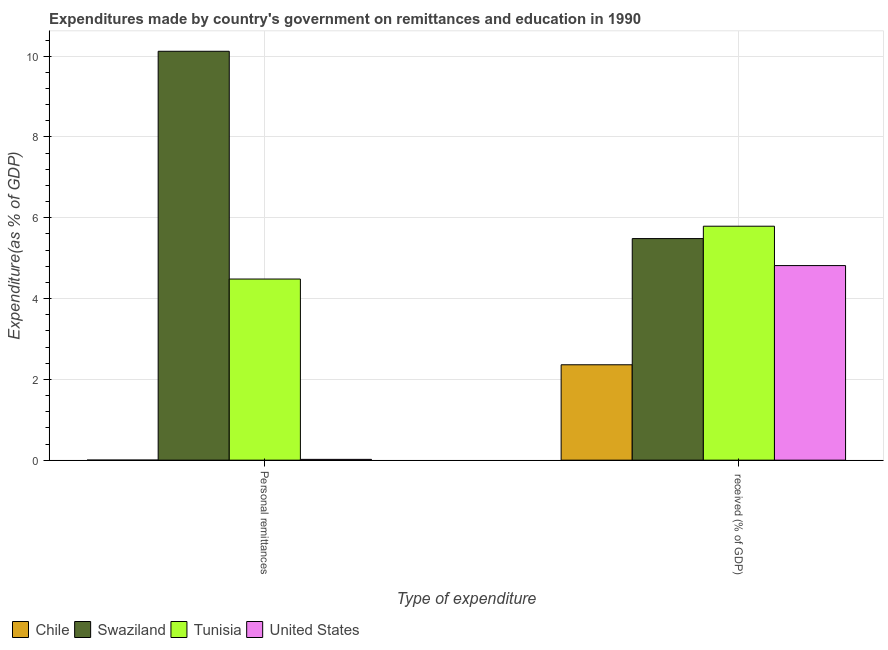Are the number of bars on each tick of the X-axis equal?
Your answer should be compact. Yes. How many bars are there on the 2nd tick from the left?
Provide a short and direct response. 4. What is the label of the 1st group of bars from the left?
Ensure brevity in your answer.  Personal remittances. What is the expenditure in education in Tunisia?
Offer a terse response. 5.79. Across all countries, what is the maximum expenditure in education?
Ensure brevity in your answer.  5.79. Across all countries, what is the minimum expenditure in education?
Your answer should be very brief. 2.36. In which country was the expenditure in personal remittances maximum?
Give a very brief answer. Swaziland. What is the total expenditure in education in the graph?
Offer a very short reply. 18.45. What is the difference between the expenditure in education in United States and that in Swaziland?
Your response must be concise. -0.67. What is the difference between the expenditure in personal remittances in Chile and the expenditure in education in Swaziland?
Provide a succinct answer. -5.48. What is the average expenditure in personal remittances per country?
Your response must be concise. 3.66. What is the difference between the expenditure in personal remittances and expenditure in education in Tunisia?
Keep it short and to the point. -1.31. What is the ratio of the expenditure in personal remittances in Swaziland to that in United States?
Your response must be concise. 517.27. Is the expenditure in personal remittances in Swaziland less than that in United States?
Your response must be concise. No. What does the 3rd bar from the left in Personal remittances represents?
Ensure brevity in your answer.  Tunisia. What does the 4th bar from the right in Personal remittances represents?
Ensure brevity in your answer.  Chile. What is the difference between two consecutive major ticks on the Y-axis?
Offer a terse response. 2. Are the values on the major ticks of Y-axis written in scientific E-notation?
Make the answer very short. No. Does the graph contain any zero values?
Keep it short and to the point. No. Does the graph contain grids?
Provide a short and direct response. Yes. What is the title of the graph?
Your answer should be compact. Expenditures made by country's government on remittances and education in 1990. What is the label or title of the X-axis?
Give a very brief answer. Type of expenditure. What is the label or title of the Y-axis?
Give a very brief answer. Expenditure(as % of GDP). What is the Expenditure(as % of GDP) in Chile in Personal remittances?
Offer a very short reply. 0. What is the Expenditure(as % of GDP) of Swaziland in Personal remittances?
Your answer should be compact. 10.12. What is the Expenditure(as % of GDP) of Tunisia in Personal remittances?
Offer a terse response. 4.48. What is the Expenditure(as % of GDP) of United States in Personal remittances?
Give a very brief answer. 0.02. What is the Expenditure(as % of GDP) of Chile in  received (% of GDP)?
Give a very brief answer. 2.36. What is the Expenditure(as % of GDP) in Swaziland in  received (% of GDP)?
Your answer should be very brief. 5.48. What is the Expenditure(as % of GDP) in Tunisia in  received (% of GDP)?
Offer a very short reply. 5.79. What is the Expenditure(as % of GDP) in United States in  received (% of GDP)?
Make the answer very short. 4.82. Across all Type of expenditure, what is the maximum Expenditure(as % of GDP) in Chile?
Provide a short and direct response. 2.36. Across all Type of expenditure, what is the maximum Expenditure(as % of GDP) in Swaziland?
Provide a succinct answer. 10.12. Across all Type of expenditure, what is the maximum Expenditure(as % of GDP) in Tunisia?
Your response must be concise. 5.79. Across all Type of expenditure, what is the maximum Expenditure(as % of GDP) in United States?
Your response must be concise. 4.82. Across all Type of expenditure, what is the minimum Expenditure(as % of GDP) of Chile?
Provide a succinct answer. 0. Across all Type of expenditure, what is the minimum Expenditure(as % of GDP) of Swaziland?
Your answer should be very brief. 5.48. Across all Type of expenditure, what is the minimum Expenditure(as % of GDP) in Tunisia?
Ensure brevity in your answer.  4.48. Across all Type of expenditure, what is the minimum Expenditure(as % of GDP) of United States?
Your answer should be very brief. 0.02. What is the total Expenditure(as % of GDP) in Chile in the graph?
Make the answer very short. 2.36. What is the total Expenditure(as % of GDP) in Swaziland in the graph?
Offer a very short reply. 15.61. What is the total Expenditure(as % of GDP) of Tunisia in the graph?
Provide a short and direct response. 10.27. What is the total Expenditure(as % of GDP) of United States in the graph?
Offer a terse response. 4.84. What is the difference between the Expenditure(as % of GDP) in Chile in Personal remittances and that in  received (% of GDP)?
Your answer should be compact. -2.36. What is the difference between the Expenditure(as % of GDP) in Swaziland in Personal remittances and that in  received (% of GDP)?
Your answer should be compact. 4.64. What is the difference between the Expenditure(as % of GDP) of Tunisia in Personal remittances and that in  received (% of GDP)?
Your response must be concise. -1.31. What is the difference between the Expenditure(as % of GDP) in United States in Personal remittances and that in  received (% of GDP)?
Offer a terse response. -4.8. What is the difference between the Expenditure(as % of GDP) of Chile in Personal remittances and the Expenditure(as % of GDP) of Swaziland in  received (% of GDP)?
Offer a terse response. -5.48. What is the difference between the Expenditure(as % of GDP) of Chile in Personal remittances and the Expenditure(as % of GDP) of Tunisia in  received (% of GDP)?
Your answer should be compact. -5.79. What is the difference between the Expenditure(as % of GDP) in Chile in Personal remittances and the Expenditure(as % of GDP) in United States in  received (% of GDP)?
Ensure brevity in your answer.  -4.82. What is the difference between the Expenditure(as % of GDP) of Swaziland in Personal remittances and the Expenditure(as % of GDP) of Tunisia in  received (% of GDP)?
Make the answer very short. 4.33. What is the difference between the Expenditure(as % of GDP) of Swaziland in Personal remittances and the Expenditure(as % of GDP) of United States in  received (% of GDP)?
Provide a short and direct response. 5.3. What is the difference between the Expenditure(as % of GDP) in Tunisia in Personal remittances and the Expenditure(as % of GDP) in United States in  received (% of GDP)?
Your response must be concise. -0.33. What is the average Expenditure(as % of GDP) in Chile per Type of expenditure?
Offer a very short reply. 1.18. What is the average Expenditure(as % of GDP) in Swaziland per Type of expenditure?
Provide a succinct answer. 7.8. What is the average Expenditure(as % of GDP) in Tunisia per Type of expenditure?
Make the answer very short. 5.14. What is the average Expenditure(as % of GDP) in United States per Type of expenditure?
Provide a short and direct response. 2.42. What is the difference between the Expenditure(as % of GDP) in Chile and Expenditure(as % of GDP) in Swaziland in Personal remittances?
Keep it short and to the point. -10.12. What is the difference between the Expenditure(as % of GDP) in Chile and Expenditure(as % of GDP) in Tunisia in Personal remittances?
Provide a short and direct response. -4.48. What is the difference between the Expenditure(as % of GDP) of Chile and Expenditure(as % of GDP) of United States in Personal remittances?
Make the answer very short. -0.02. What is the difference between the Expenditure(as % of GDP) in Swaziland and Expenditure(as % of GDP) in Tunisia in Personal remittances?
Provide a succinct answer. 5.64. What is the difference between the Expenditure(as % of GDP) of Swaziland and Expenditure(as % of GDP) of United States in Personal remittances?
Make the answer very short. 10.1. What is the difference between the Expenditure(as % of GDP) in Tunisia and Expenditure(as % of GDP) in United States in Personal remittances?
Provide a short and direct response. 4.46. What is the difference between the Expenditure(as % of GDP) in Chile and Expenditure(as % of GDP) in Swaziland in  received (% of GDP)?
Your response must be concise. -3.12. What is the difference between the Expenditure(as % of GDP) in Chile and Expenditure(as % of GDP) in Tunisia in  received (% of GDP)?
Offer a terse response. -3.43. What is the difference between the Expenditure(as % of GDP) in Chile and Expenditure(as % of GDP) in United States in  received (% of GDP)?
Offer a terse response. -2.46. What is the difference between the Expenditure(as % of GDP) in Swaziland and Expenditure(as % of GDP) in Tunisia in  received (% of GDP)?
Keep it short and to the point. -0.31. What is the difference between the Expenditure(as % of GDP) of Swaziland and Expenditure(as % of GDP) of United States in  received (% of GDP)?
Provide a succinct answer. 0.67. What is the difference between the Expenditure(as % of GDP) of Tunisia and Expenditure(as % of GDP) of United States in  received (% of GDP)?
Give a very brief answer. 0.97. What is the ratio of the Expenditure(as % of GDP) in Chile in Personal remittances to that in  received (% of GDP)?
Give a very brief answer. 0. What is the ratio of the Expenditure(as % of GDP) of Swaziland in Personal remittances to that in  received (% of GDP)?
Give a very brief answer. 1.85. What is the ratio of the Expenditure(as % of GDP) of Tunisia in Personal remittances to that in  received (% of GDP)?
Provide a succinct answer. 0.77. What is the ratio of the Expenditure(as % of GDP) in United States in Personal remittances to that in  received (% of GDP)?
Give a very brief answer. 0. What is the difference between the highest and the second highest Expenditure(as % of GDP) of Chile?
Your answer should be compact. 2.36. What is the difference between the highest and the second highest Expenditure(as % of GDP) of Swaziland?
Make the answer very short. 4.64. What is the difference between the highest and the second highest Expenditure(as % of GDP) of Tunisia?
Keep it short and to the point. 1.31. What is the difference between the highest and the second highest Expenditure(as % of GDP) of United States?
Provide a succinct answer. 4.8. What is the difference between the highest and the lowest Expenditure(as % of GDP) of Chile?
Make the answer very short. 2.36. What is the difference between the highest and the lowest Expenditure(as % of GDP) in Swaziland?
Give a very brief answer. 4.64. What is the difference between the highest and the lowest Expenditure(as % of GDP) of Tunisia?
Your answer should be very brief. 1.31. What is the difference between the highest and the lowest Expenditure(as % of GDP) of United States?
Your answer should be compact. 4.8. 